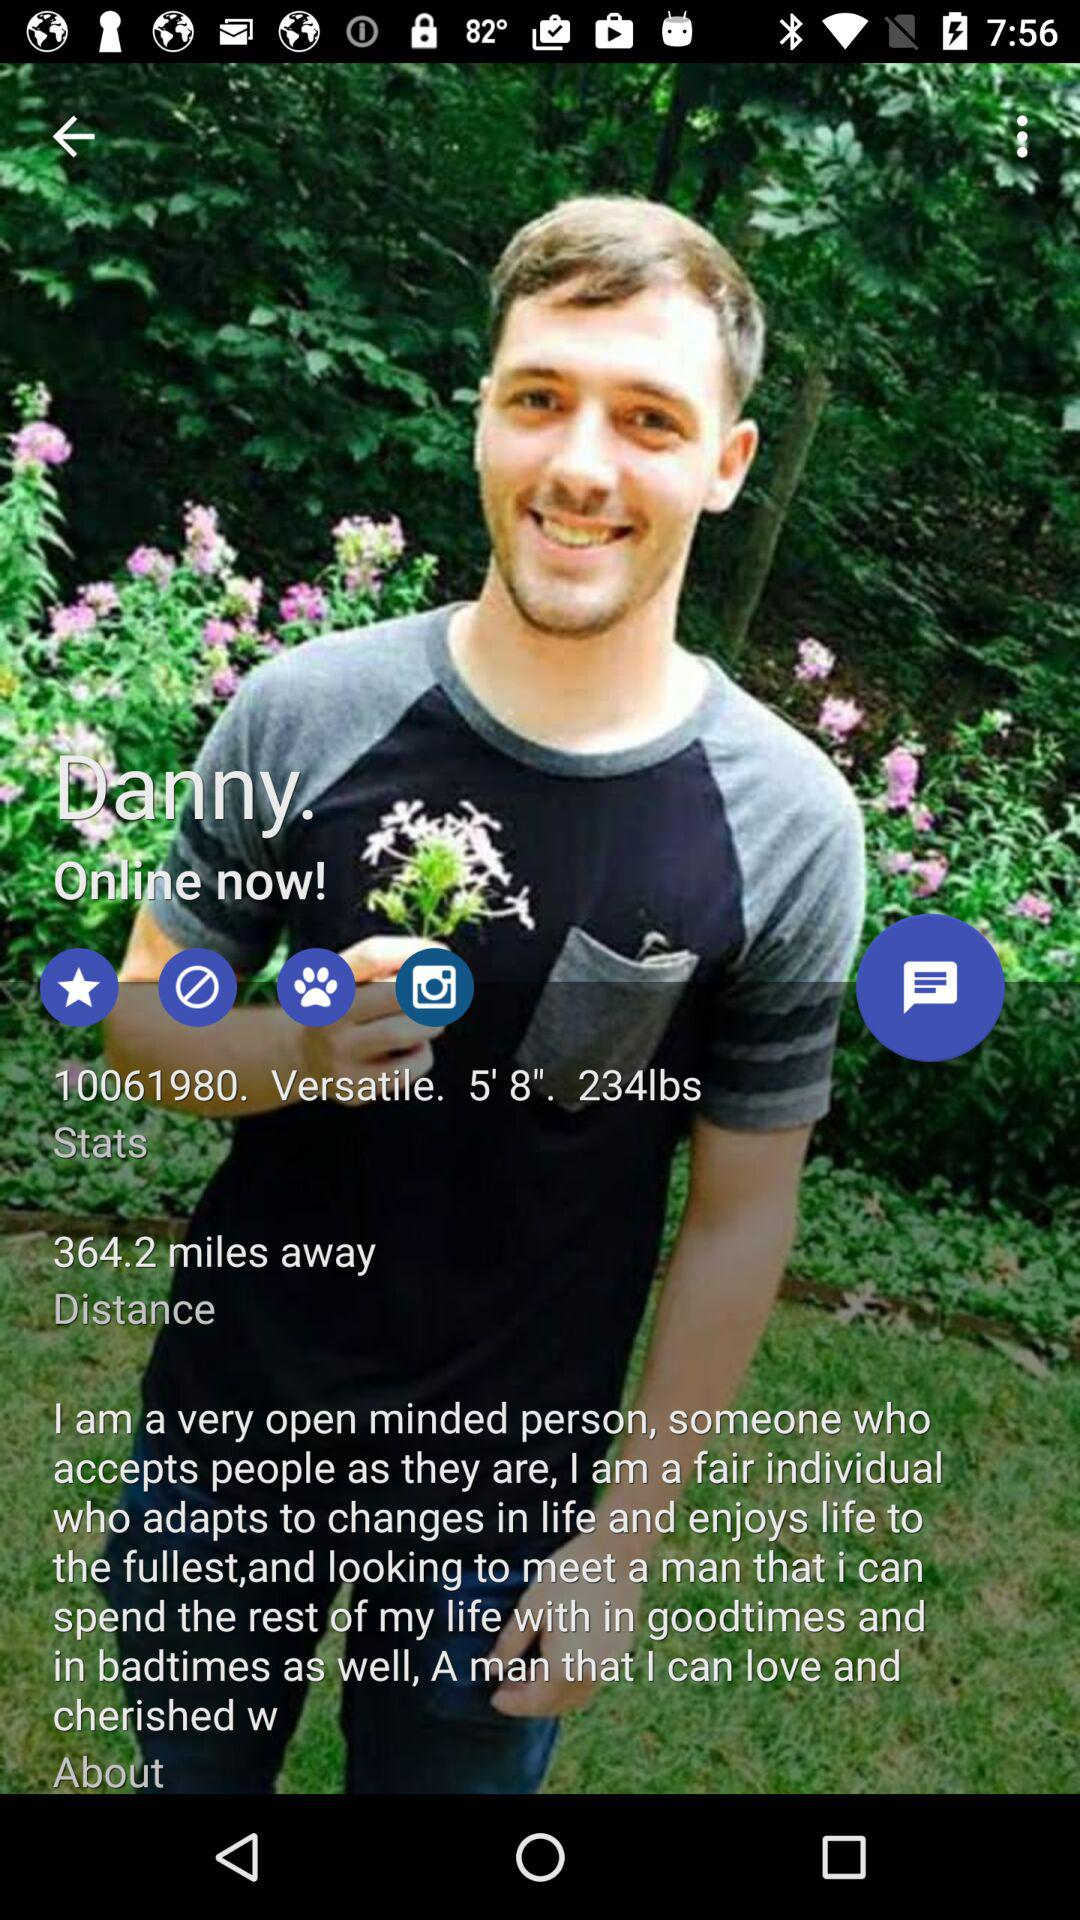What is the height of Danny? The height of Danny is 5 feet 8 inches. 